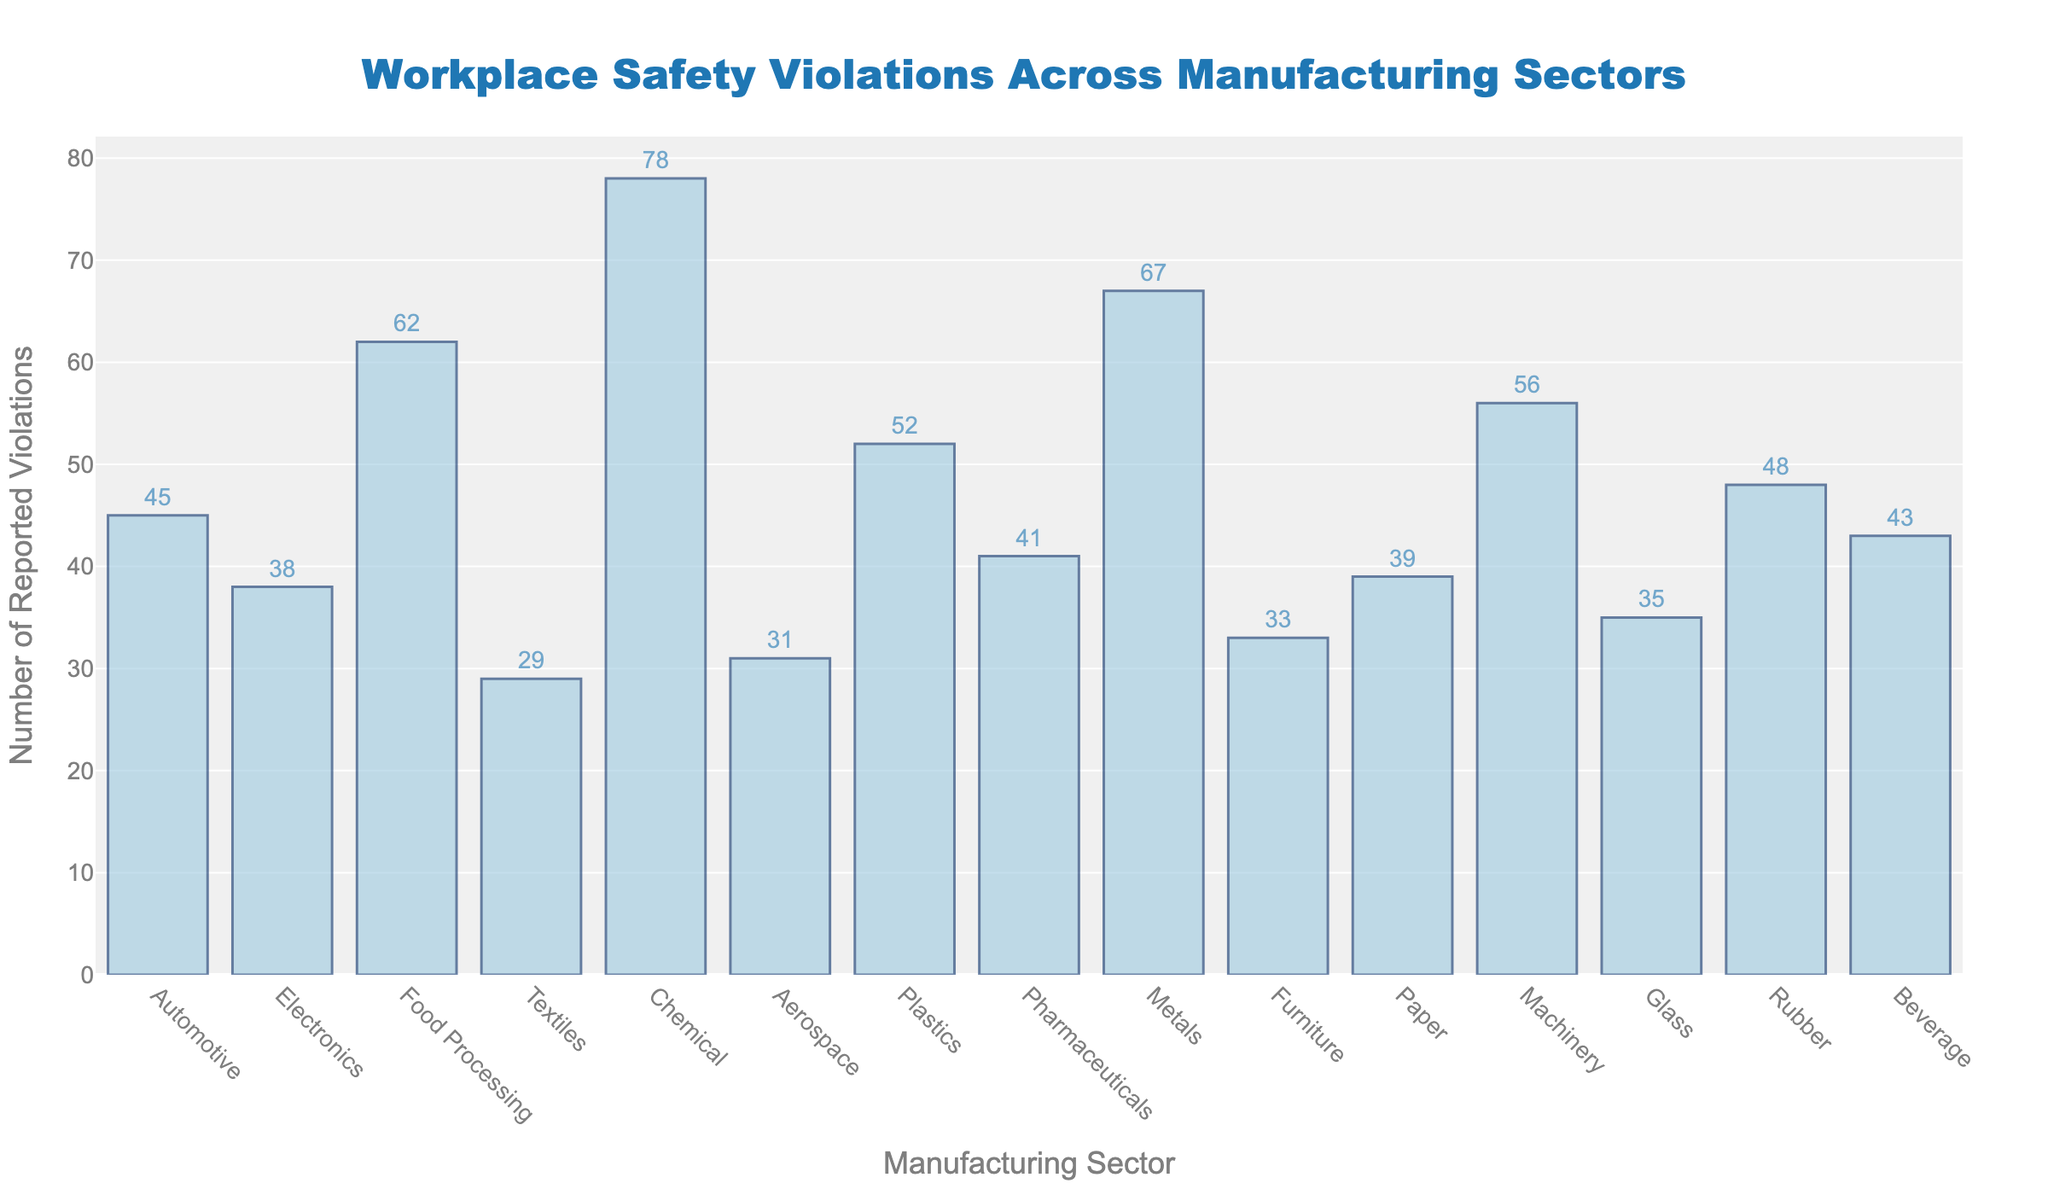What is the title of the figure? The title of the figure is displayed prominently at the top of the chart. It reads "Workplace Safety Violations Across Manufacturing Sectors".
Answer: Workplace Safety Violations Across Manufacturing Sectors What is the sector with the highest number of reported violations? To find the sector with the highest number of violations, locate the tallest bar in the bar chart. The tallest bar corresponds to the "Chemical" sector with 78 violations.
Answer: Chemical Which sector has the least number of reported violations? The shortest bar represents the sector with the least number of violations, which is "Textiles" with 29 violations.
Answer: Textiles What is the difference in reported violations between the Automotive and Pharmaceutical sectors? The number of reported violations in the Automotive sector is 45. In the Pharmaceutical sector, it is 41. The difference is 45 - 41 = 4.
Answer: 4 How many sectors reported more than 50 violations? Count the number of bars representing more than 50 violations. The sectors are Chemical (78), Food Processing (62), Metals (67), Machinery (56), and Plastics (52), resulting in 5 sectors.
Answer: 5 What is the median value of reported violations across the sectors? List all violations in ascending order: 29, 31, 33, 35, 38, 39, 41, 43, 45, 48, 52, 56, 62, 67, 78. The median is the middle value in this list. With 15 data points, the median is the 8th value, which is 43.
Answer: 43 Compare the number of reported violations in the Electronics sector to the Aerospace sector. Which is greater? The number of reported violations in the Electronics sector is 38, and in the Aerospace sector, it is 31. Electronics have greater violations.
Answer: Electronics What is the average number of reported violations across all sectors? Sum all reported violations: 45 + 38 + 62 + 29 + 78 + 31 + 52 + 41 + 67 + 33 + 39 + 56 + 35 + 48 + 43 = 697. There are 15 sectors, so the average is 697 / 15 ≈ 46.47.
Answer: 46.47 Which sectors have a similar number of violations, within 5 violations of each other? Compare each sector's violations. Sectors close to each other within a 5-violation range include: Electronics (38) and Paper (39), Textiles (29) and Aerospace (31), Glass (35) and Furniture (33). These sectors are paired: Electronics and Paper, Textiles and Aerospace, Glass and Furniture.
Answer: Electronics and Paper, Textiles and Aerospace, Glass and Furniture 